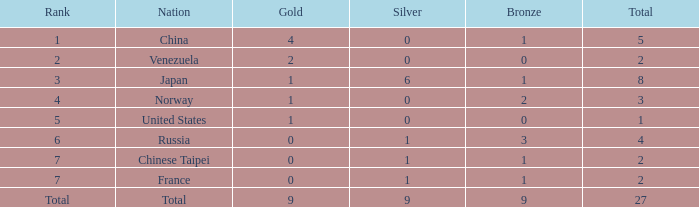When there are over 1 gold and the nation's total is taken into account, what is the sum of bronze medals? 1.0. 